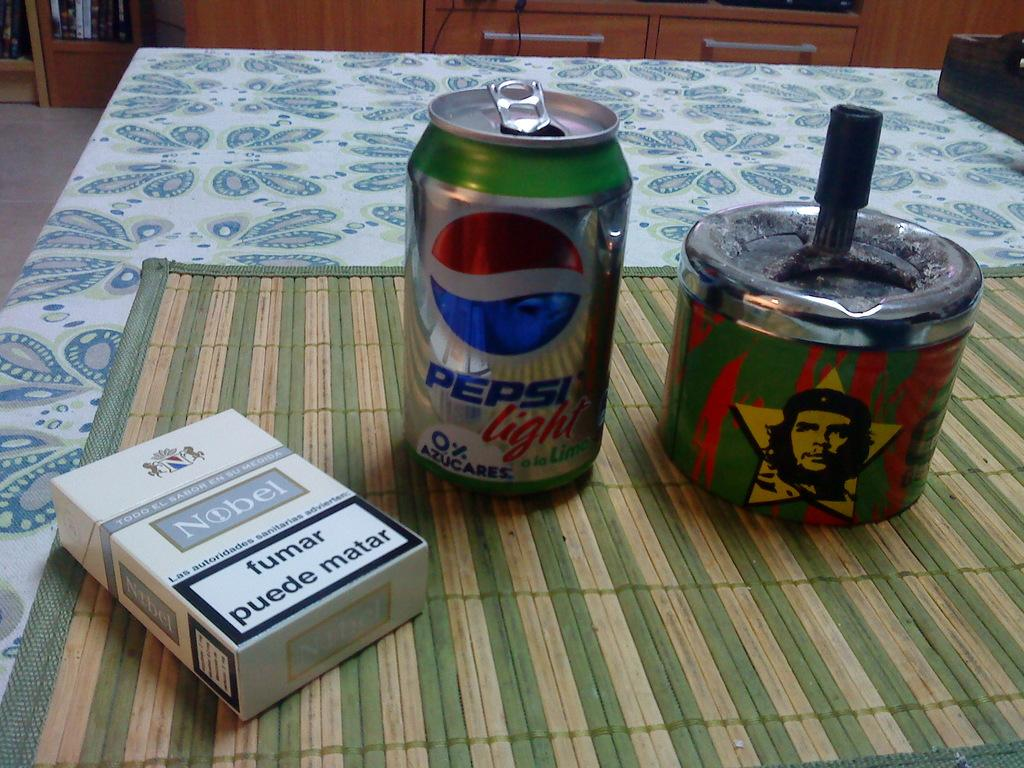<image>
Describe the image concisely. A pack of Nobel cigarettes lie on a table next to a Pepsi Light can. 